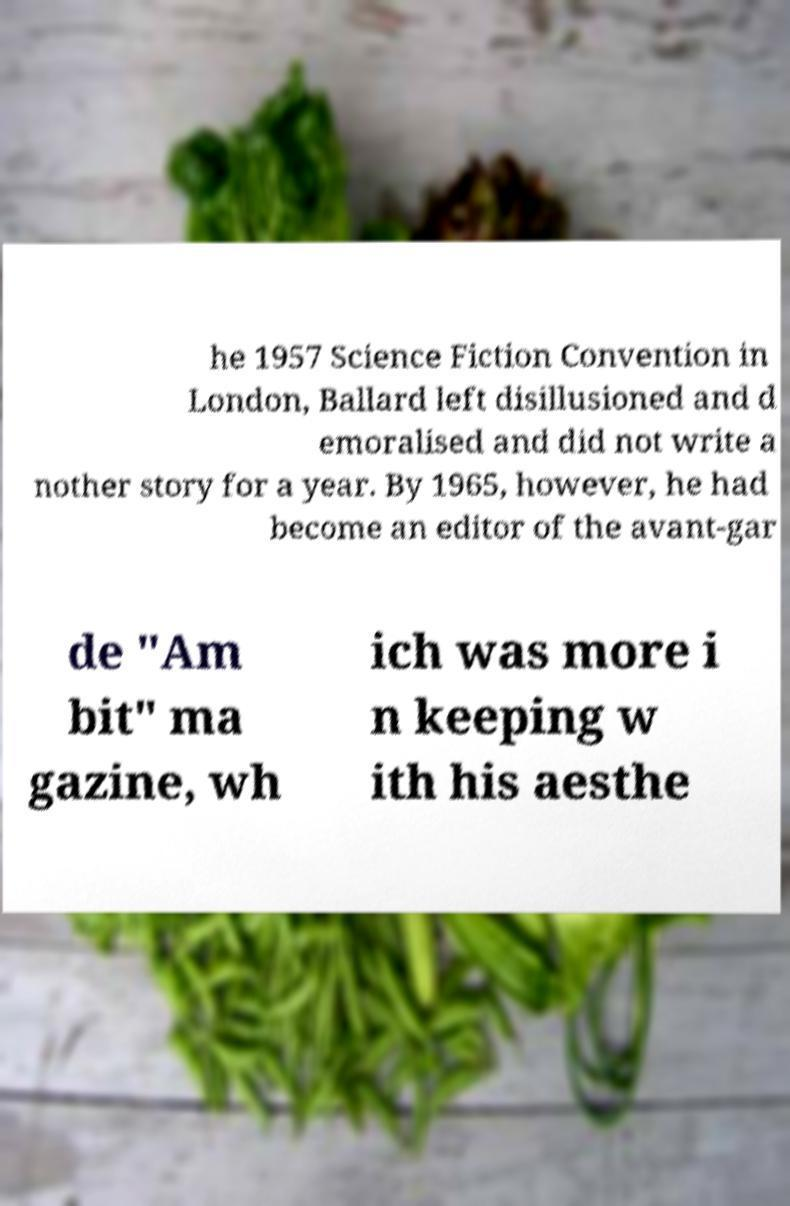I need the written content from this picture converted into text. Can you do that? he 1957 Science Fiction Convention in London, Ballard left disillusioned and d emoralised and did not write a nother story for a year. By 1965, however, he had become an editor of the avant-gar de "Am bit" ma gazine, wh ich was more i n keeping w ith his aesthe 